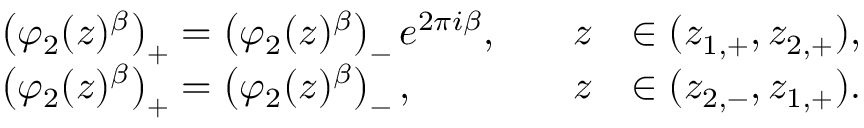<formula> <loc_0><loc_0><loc_500><loc_500>\begin{array} { r l r l } & { \left ( \varphi _ { 2 } ( z ) ^ { \beta } \right ) _ { + } = \left ( \varphi _ { 2 } ( z ) ^ { \beta } \right ) _ { - } e ^ { 2 \pi i { \beta } } , \quad } & { z } & { \in ( z _ { 1 , + } , z _ { 2 , + } ) , } \\ & { \left ( \varphi _ { 2 } ( z ) ^ { \beta } \right ) _ { + } = \left ( \varphi _ { 2 } ( z ) ^ { \beta } \right ) _ { - } , \quad } & { z } & { \in ( z _ { 2 , - } , z _ { 1 , + } ) . } \end{array}</formula> 